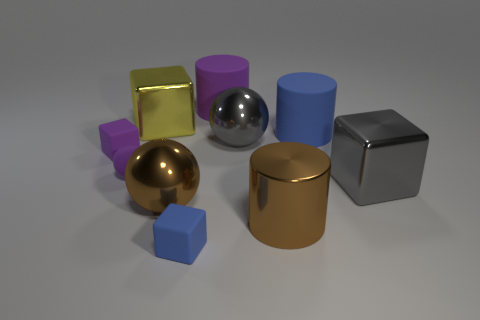There is a blue object that is the same shape as the large yellow metallic object; what is its material?
Your answer should be compact. Rubber. What number of small objects are either gray metallic objects or metallic objects?
Your answer should be compact. 0. What is the material of the large yellow thing?
Ensure brevity in your answer.  Metal. There is a cube that is both behind the brown metallic cylinder and on the right side of the yellow block; what is its material?
Your answer should be very brief. Metal. There is a large metallic cylinder; does it have the same color as the tiny matte cube that is in front of the gray cube?
Offer a very short reply. No. There is a yellow cube that is the same size as the purple rubber cylinder; what is it made of?
Provide a short and direct response. Metal. Are there any brown things made of the same material as the large purple cylinder?
Your answer should be very brief. No. How many big brown cylinders are there?
Keep it short and to the point. 1. Does the large purple cylinder have the same material as the thing in front of the brown metallic cylinder?
Your answer should be compact. Yes. What material is the large sphere that is the same color as the metal cylinder?
Provide a short and direct response. Metal. 